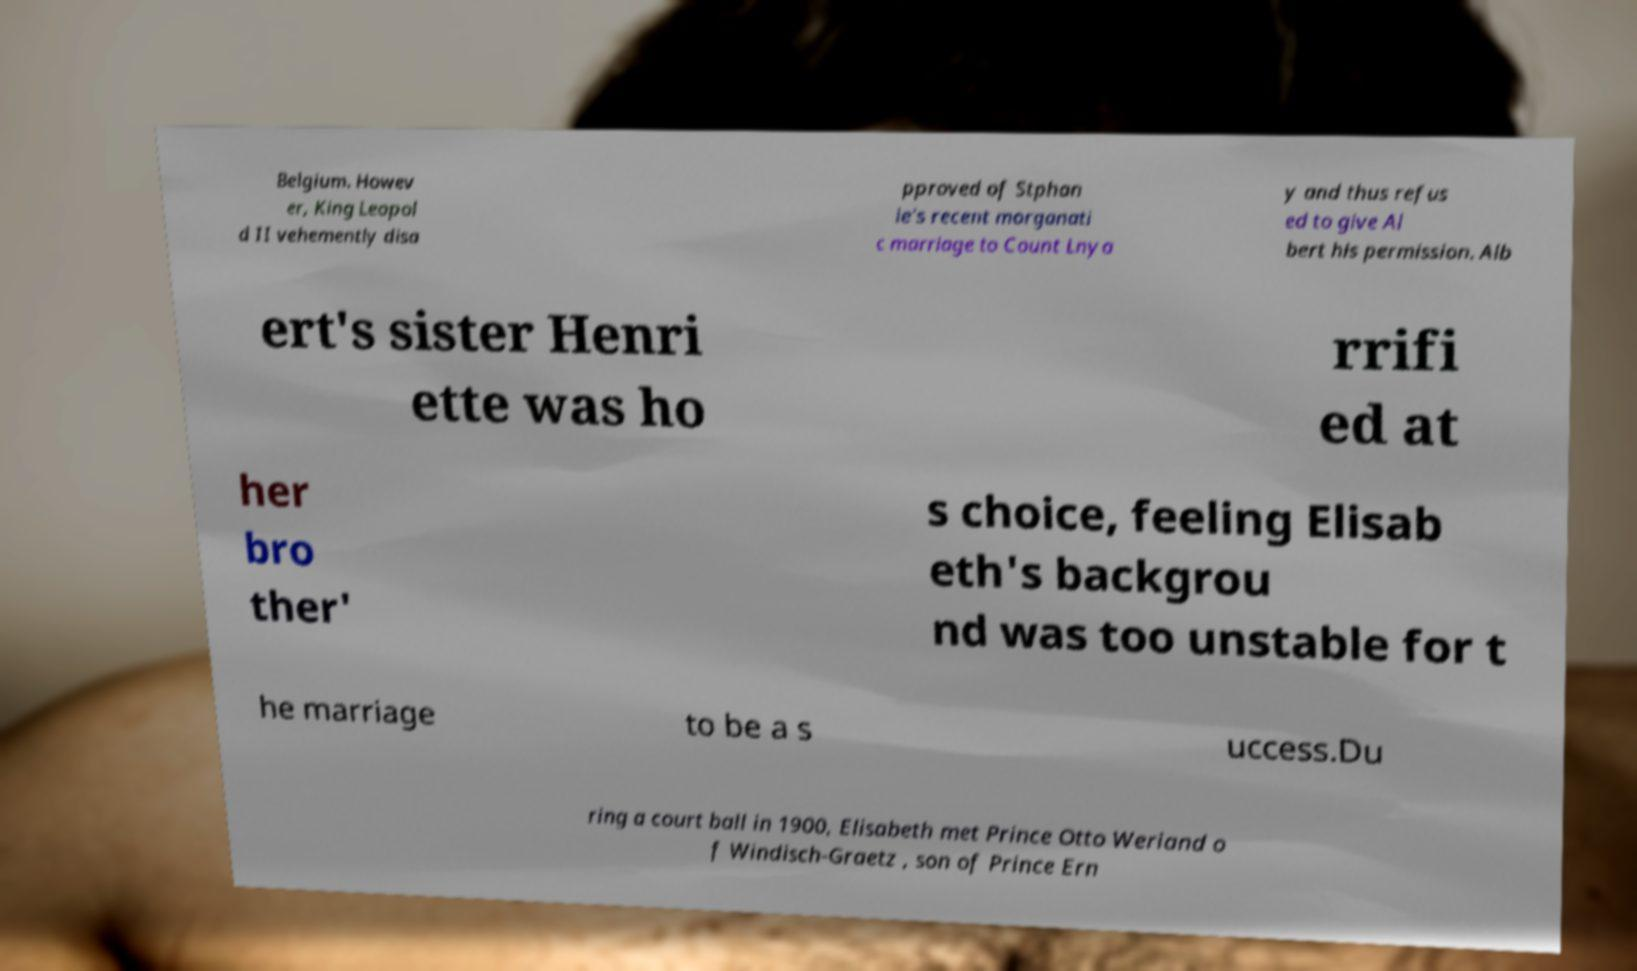Can you read and provide the text displayed in the image?This photo seems to have some interesting text. Can you extract and type it out for me? Belgium. Howev er, King Leopol d II vehemently disa pproved of Stphan ie's recent morganati c marriage to Count Lnya y and thus refus ed to give Al bert his permission. Alb ert's sister Henri ette was ho rrifi ed at her bro ther' s choice, feeling Elisab eth's backgrou nd was too unstable for t he marriage to be a s uccess.Du ring a court ball in 1900, Elisabeth met Prince Otto Weriand o f Windisch-Graetz , son of Prince Ern 